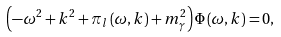<formula> <loc_0><loc_0><loc_500><loc_500>\left ( - \omega ^ { 2 } + k ^ { 2 } + \pi _ { l } \left ( \omega , k \right ) + m _ { \gamma } ^ { 2 } \right ) \Phi \left ( \omega , k \right ) = 0 ,</formula> 